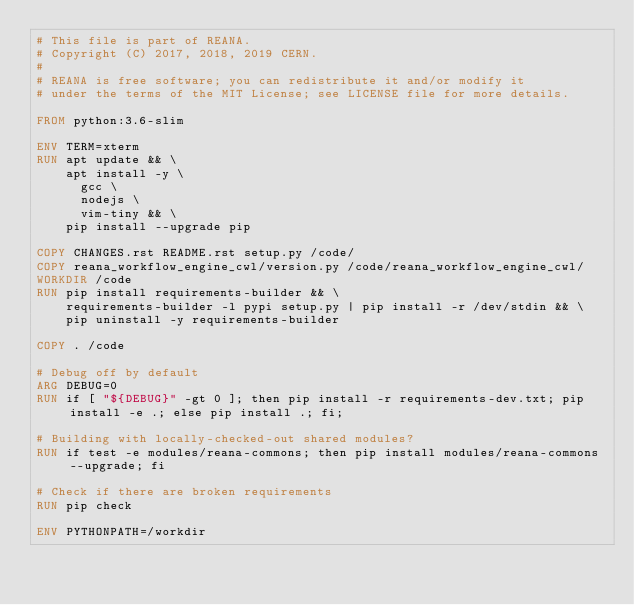Convert code to text. <code><loc_0><loc_0><loc_500><loc_500><_Dockerfile_># This file is part of REANA.
# Copyright (C) 2017, 2018, 2019 CERN.
#
# REANA is free software; you can redistribute it and/or modify it
# under the terms of the MIT License; see LICENSE file for more details.

FROM python:3.6-slim

ENV TERM=xterm
RUN apt update && \
    apt install -y \
      gcc \
      nodejs \
      vim-tiny && \
    pip install --upgrade pip

COPY CHANGES.rst README.rst setup.py /code/
COPY reana_workflow_engine_cwl/version.py /code/reana_workflow_engine_cwl/
WORKDIR /code
RUN pip install requirements-builder && \
    requirements-builder -l pypi setup.py | pip install -r /dev/stdin && \
    pip uninstall -y requirements-builder

COPY . /code

# Debug off by default
ARG DEBUG=0
RUN if [ "${DEBUG}" -gt 0 ]; then pip install -r requirements-dev.txt; pip install -e .; else pip install .; fi;

# Building with locally-checked-out shared modules?
RUN if test -e modules/reana-commons; then pip install modules/reana-commons --upgrade; fi

# Check if there are broken requirements
RUN pip check

ENV PYTHONPATH=/workdir
</code> 